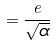<formula> <loc_0><loc_0><loc_500><loc_500>= \frac { e } { \sqrt { \alpha } }</formula> 